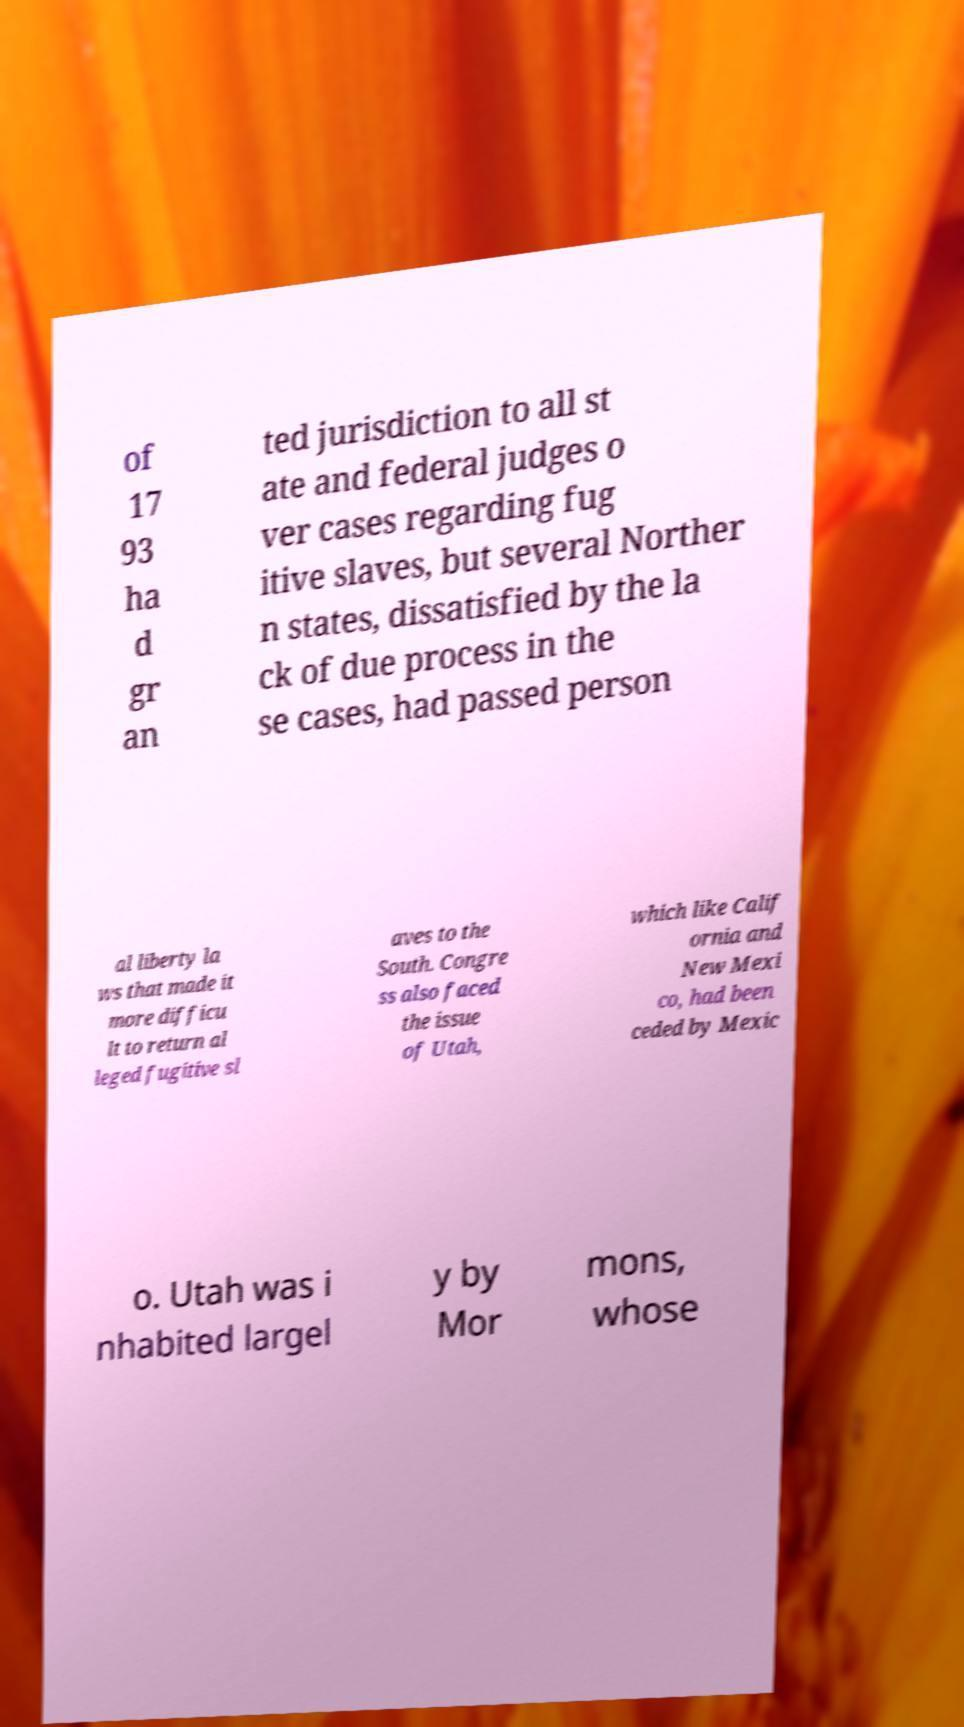Can you accurately transcribe the text from the provided image for me? of 17 93 ha d gr an ted jurisdiction to all st ate and federal judges o ver cases regarding fug itive slaves, but several Norther n states, dissatisfied by the la ck of due process in the se cases, had passed person al liberty la ws that made it more difficu lt to return al leged fugitive sl aves to the South. Congre ss also faced the issue of Utah, which like Calif ornia and New Mexi co, had been ceded by Mexic o. Utah was i nhabited largel y by Mor mons, whose 